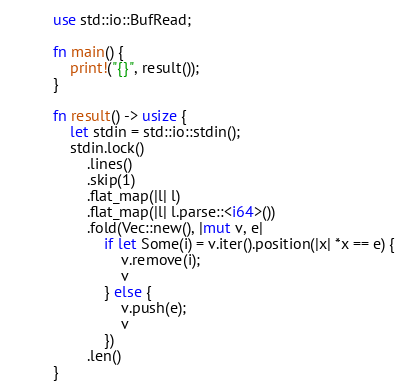<code> <loc_0><loc_0><loc_500><loc_500><_Rust_>use std::io::BufRead;

fn main() {
	print!("{}", result());
}

fn result() -> usize {
	let stdin = std::io::stdin();
	stdin.lock()
		.lines()
		.skip(1)
		.flat_map(|l| l)
		.flat_map(|l| l.parse::<i64>())
		.fold(Vec::new(), |mut v, e|
			if let Some(i) = v.iter().position(|x| *x == e) {
				v.remove(i);
				v
			} else {
				v.push(e);
				v
			})
		.len()
}
</code> 